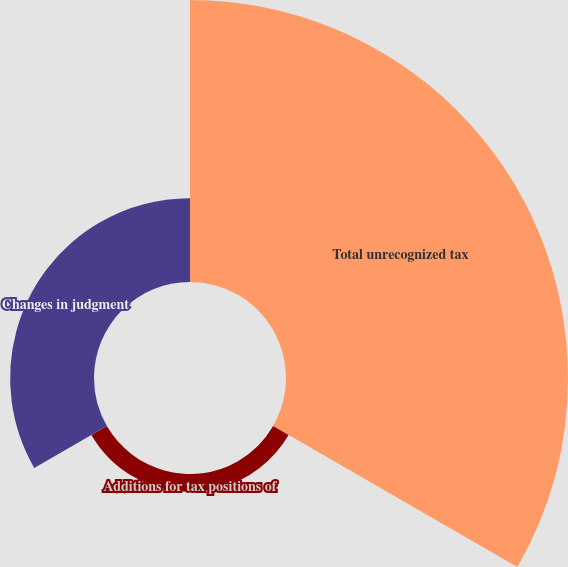<chart> <loc_0><loc_0><loc_500><loc_500><pie_chart><fcel>Total unrecognized tax<fcel>Additions for tax positions of<fcel>Changes in judgment<nl><fcel>73.5%<fcel>4.64%<fcel>21.86%<nl></chart> 